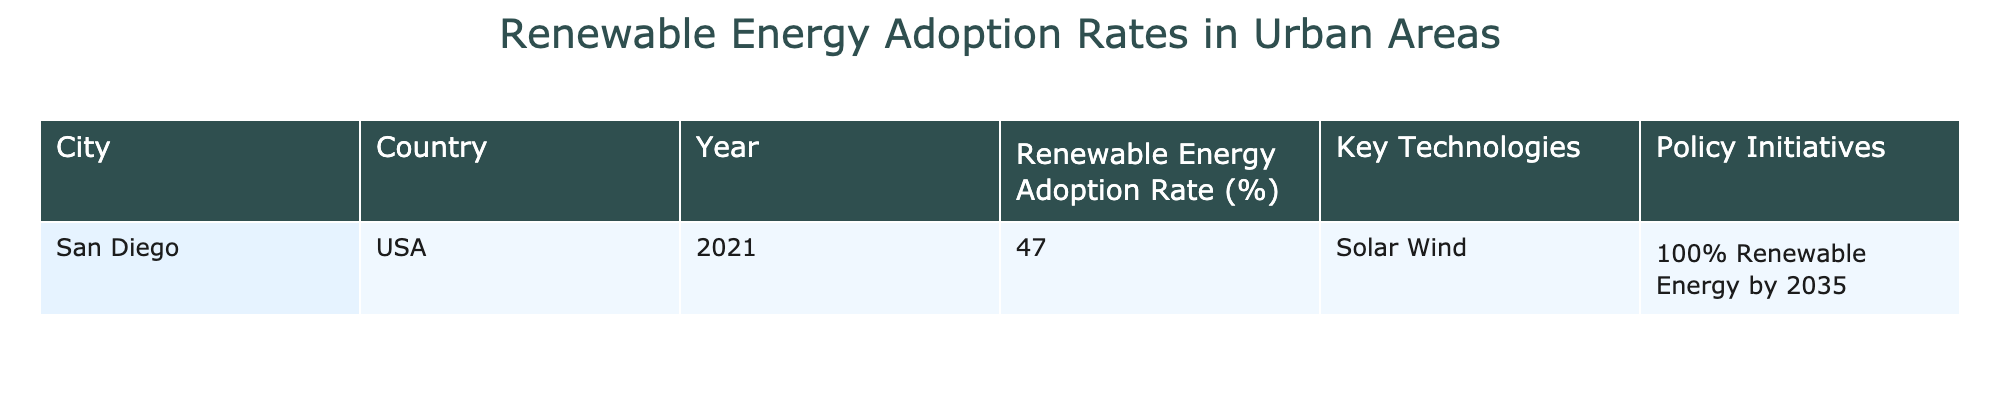What is the renewable energy adoption rate for San Diego in 2021? The table shows that for San Diego, USA, in the year 2021, the renewable energy adoption rate is listed as 47%.
Answer: 47% Which key technologies are used in San Diego for renewable energy? The table indicates that San Diego employs both solar and wind technologies for renewable energy.
Answer: Solar, Wind Does the adoption rate in San Diego exceed 40%? Since the adoption rate for San Diego is 47%, which is greater than 40%, the answer is yes.
Answer: Yes What policy initiative is San Diego aiming for by 2035? According to the table, San Diego's policy initiative is to achieve 100% renewable energy by 2035.
Answer: 100% Renewable Energy by 2035 If we consider the renewable energy adoption rate in San Diego, what percentage does it fall below 50%? The adoption rate in San Diego is 47%, which is below 50%. The difference is 50% - 47% = 3%.
Answer: 3% Is the renewable energy adoption rate the same across all listed cities? The table only shows information for San Diego, and therefore, we cannot determine if rates are the same across other cities based on this data. The answer is no.
Answer: No What are the key factors contributing to the renewable energy strategy in San Diego? The table lists key technologies (solar and wind) and a policy initiative (100% renewable energy by 2035) as contributing factors to San Diego's renewable energy strategy.
Answer: Solar, Wind, 100% Renewable Energy by 2035 If another city reported a 60% adoption rate, how much higher is it compared to San Diego's rate? San Diego's renewable energy adoption rate is 47%. If another city has a 60% adoption rate, the difference is 60% - 47% = 13%.
Answer: 13% 